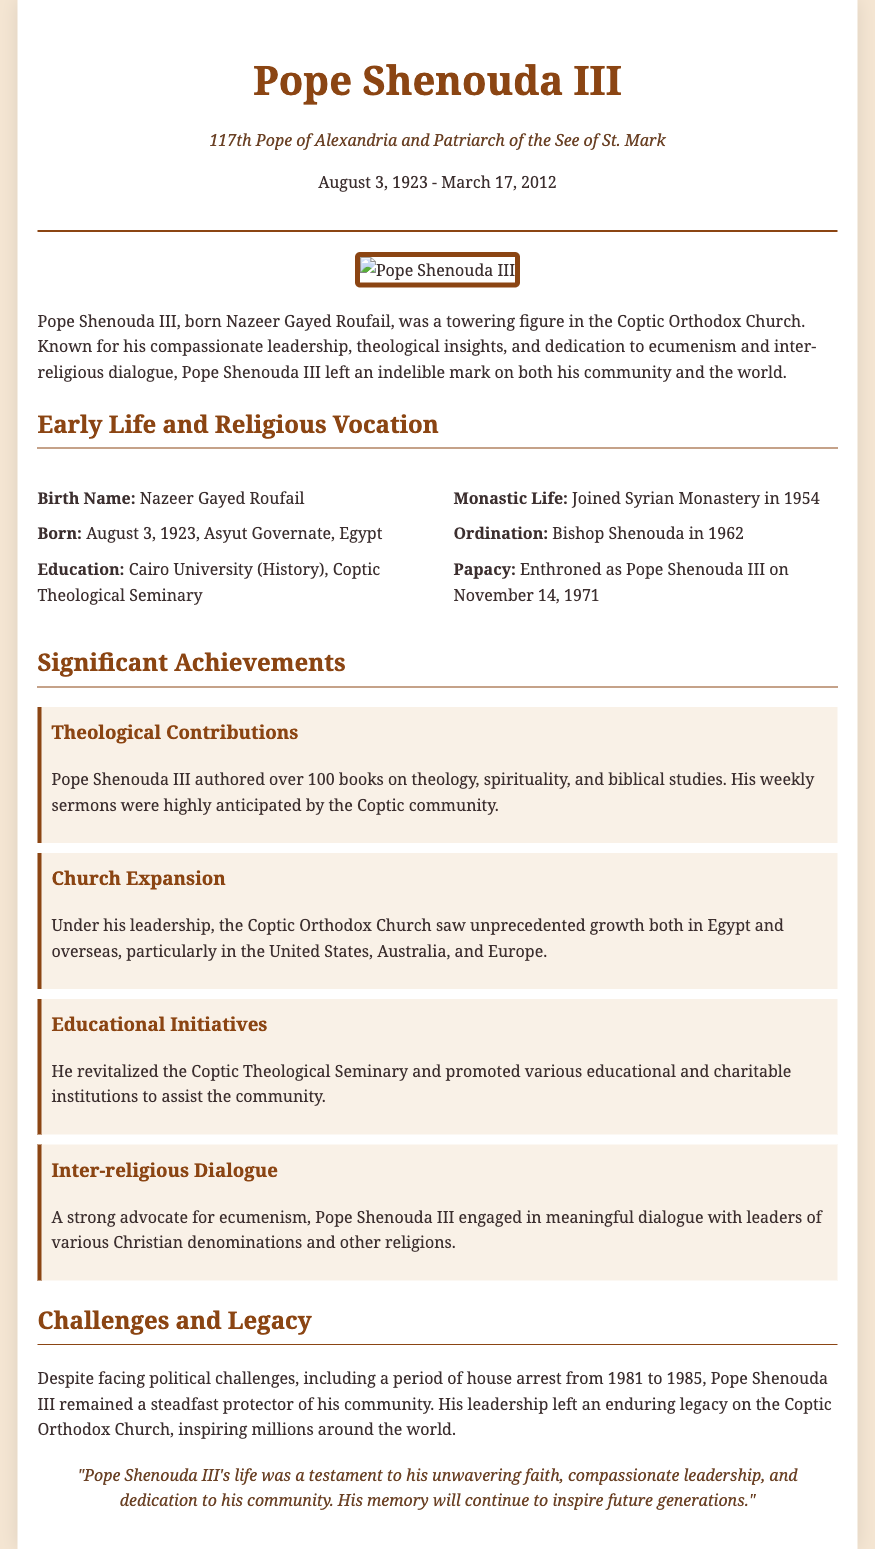What was Pope Shenouda III's birth name? The document states that his birth name was Nazeer Gayed Roufail.
Answer: Nazeer Gayed Roufail When was Pope Shenouda III born? According to the obituary, he was born on August 3, 1923.
Answer: August 3, 1923 In which year was Pope Shenouda III enthroned as pope? The document mentions that he was enthroned on November 14, 1971.
Answer: November 14, 1971 How many books did Pope Shenouda III author? The obituary indicates that he authored over 100 books on various topics.
Answer: over 100 What role did Pope Shenouda III play in the church's expansion? The text explains that under his leadership, the church saw unprecedented growth both in Egypt and overseas.
Answer: unprecedented growth What was one of the significant challenges Pope Shenouda III faced? The document outlines that he faced a period of house arrest from 1981 to 1985.
Answer: house arrest What was Pope Shenouda III's influence on inter-religious dialogue? The obituary describes him as a strong advocate for ecumenism, engaging in meaningful dialogue with various religious leaders.
Answer: advocate for ecumenism What is emphasized as a key aspect of Pope Shenouda III's leadership? The text highlights his compassionate leadership and dedication to his community as key aspects of his papacy.
Answer: compassionate leadership What did Pope Shenouda III do to promote education? The document states that he revitalized the Coptic Theological Seminary and promoted educational institutions.
Answer: revitalized the Coptic Theological Seminary 